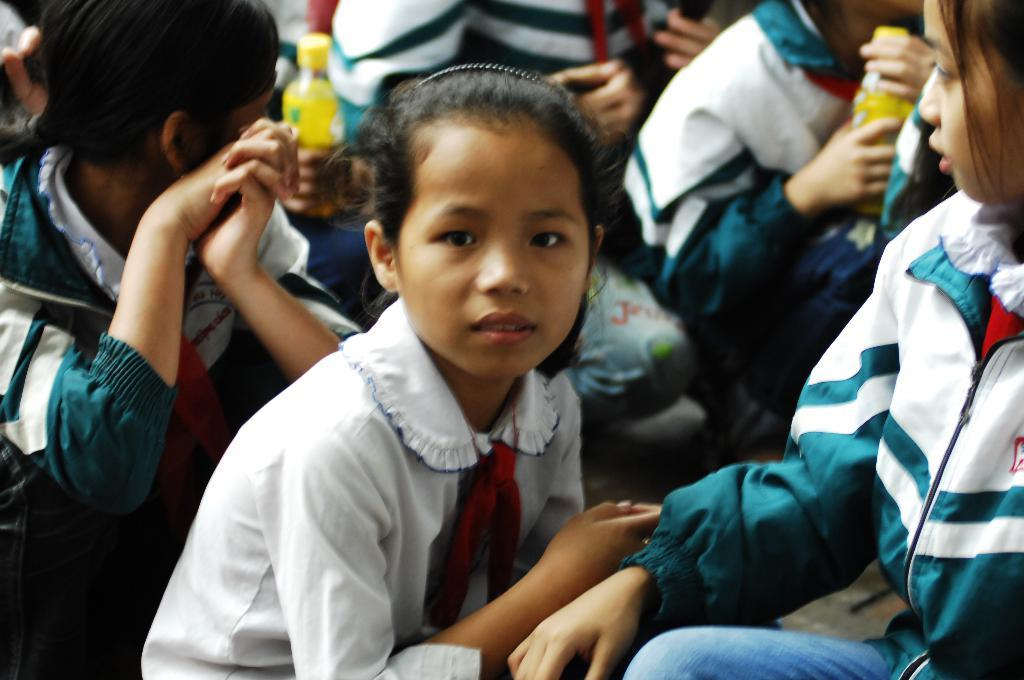Who or what can be seen in the image? There are people in the image. Can you describe the actions of the people in the background? Two persons in the background are holding bottles. What type of plastic is used to make the pancake in the image? There is no pancake present in the image, and therefore no plastic is involved. 